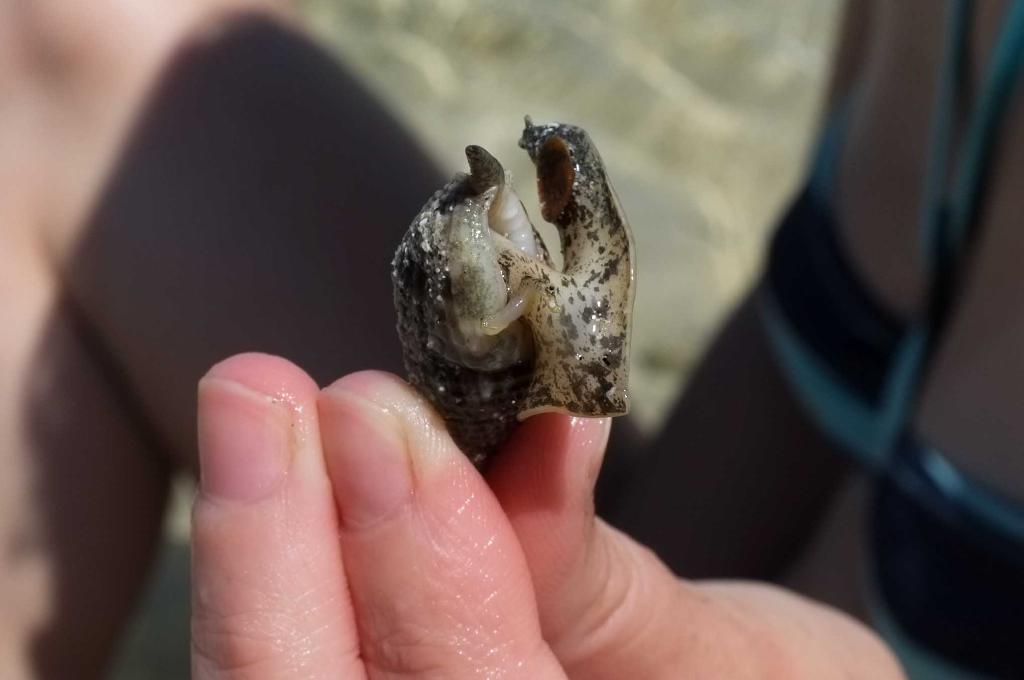Describe this image in one or two sentences. In this picture we can see a person is holding a snail. 